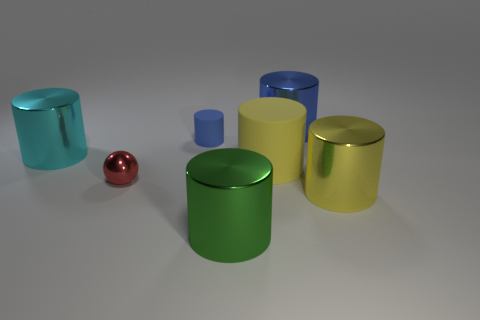Add 2 tiny gray objects. How many objects exist? 9 Subtract all green cylinders. How many cylinders are left? 5 Subtract all tiny blue cylinders. How many cylinders are left? 5 Subtract 1 cylinders. How many cylinders are left? 5 Subtract all spheres. How many objects are left? 6 Subtract all cyan cylinders. Subtract all blue cubes. How many cylinders are left? 5 Subtract all brown blocks. How many yellow cylinders are left? 2 Subtract all small blue things. Subtract all big matte things. How many objects are left? 5 Add 3 big yellow metal things. How many big yellow metal things are left? 4 Add 6 yellow objects. How many yellow objects exist? 8 